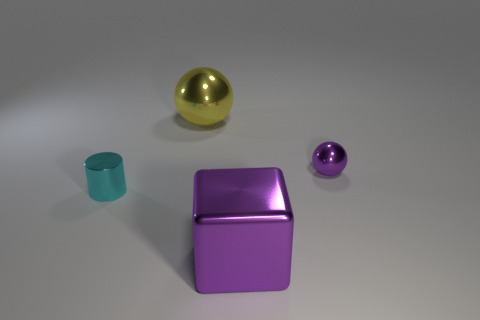Add 1 shiny things. How many objects exist? 5 Subtract all cylinders. How many objects are left? 3 Subtract all metallic blocks. Subtract all spheres. How many objects are left? 1 Add 2 big yellow balls. How many big yellow balls are left? 3 Add 1 large green things. How many large green things exist? 1 Subtract 1 yellow spheres. How many objects are left? 3 